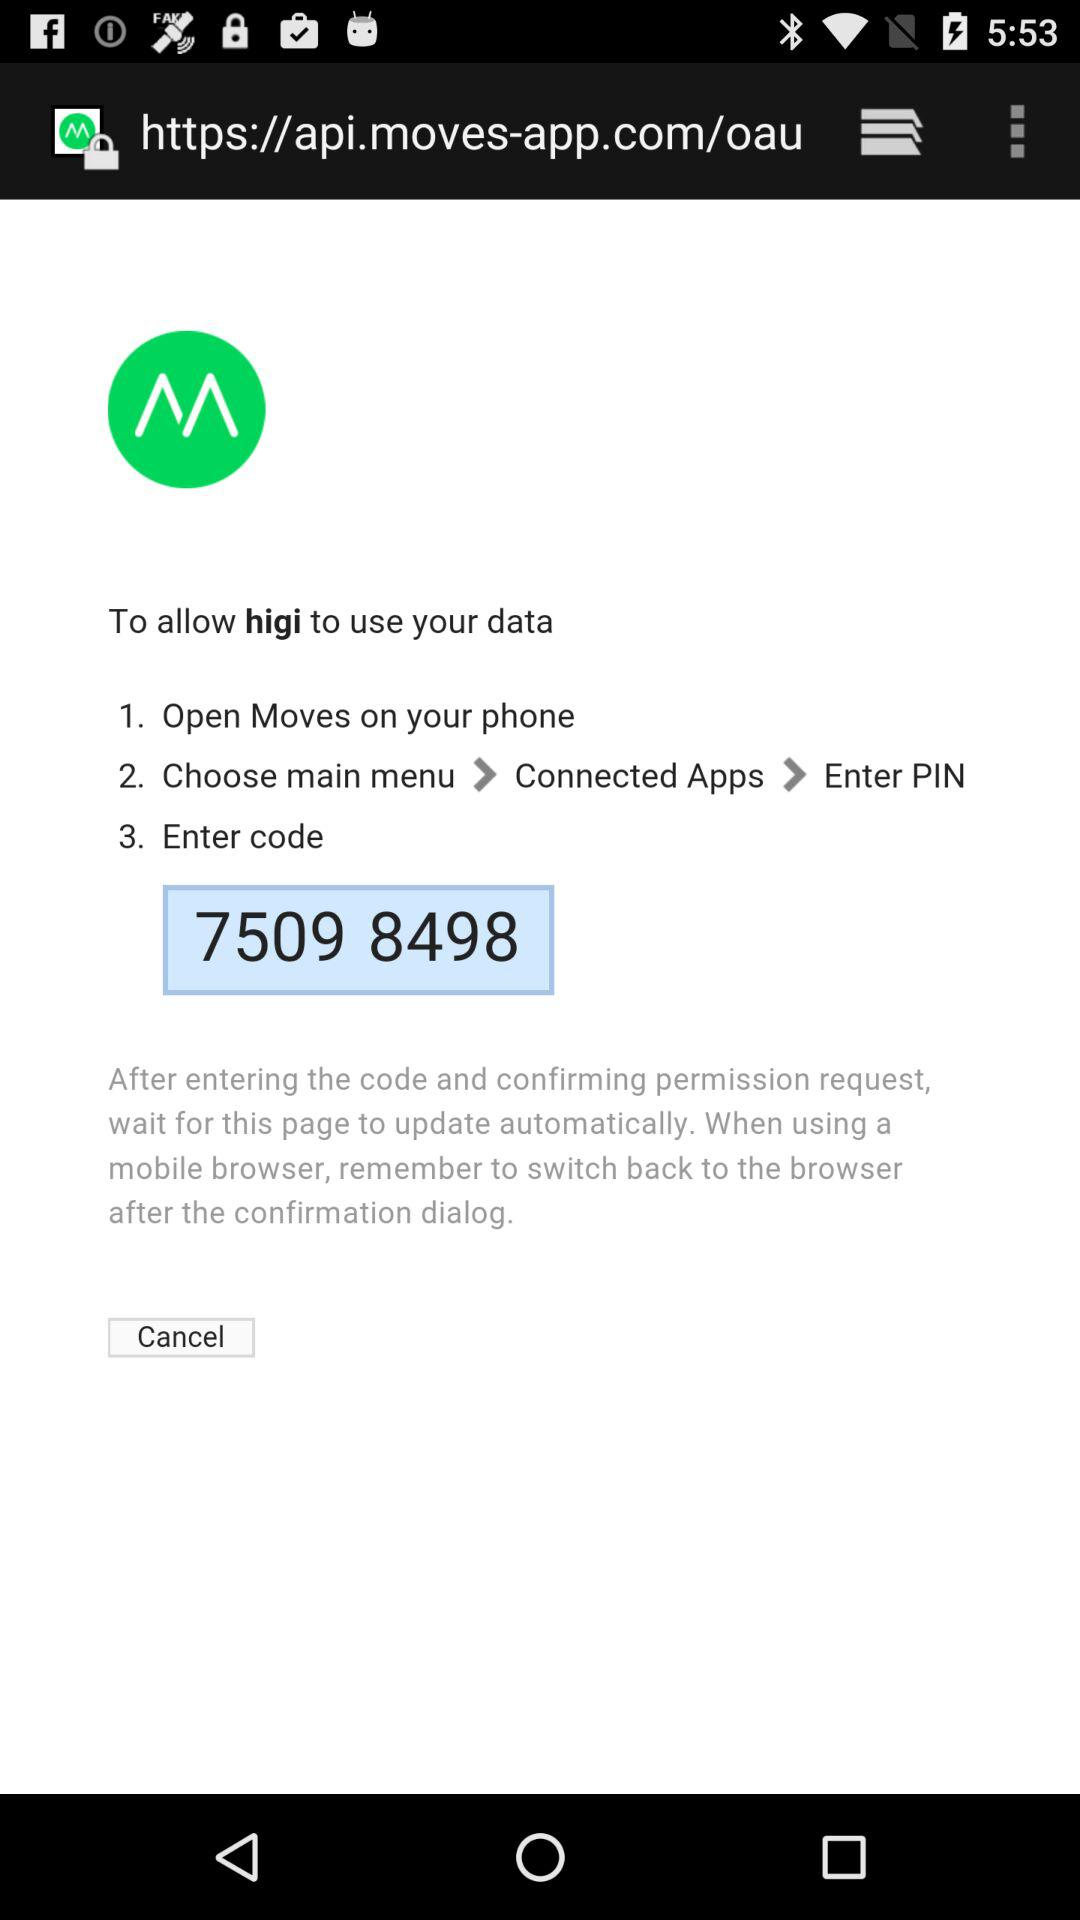What is the user's name?
When the provided information is insufficient, respond with <no answer>. <no answer> 